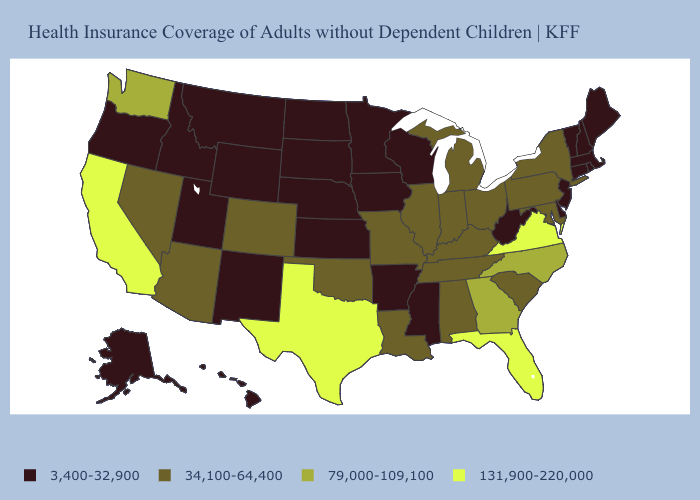Name the states that have a value in the range 79,000-109,100?
Be succinct. Georgia, North Carolina, Washington. Among the states that border Florida , which have the highest value?
Write a very short answer. Georgia. Does the map have missing data?
Keep it brief. No. Among the states that border Rhode Island , which have the lowest value?
Concise answer only. Connecticut, Massachusetts. What is the lowest value in the USA?
Keep it brief. 3,400-32,900. Among the states that border California , which have the lowest value?
Quick response, please. Oregon. What is the value of Nevada?
Concise answer only. 34,100-64,400. What is the value of Vermont?
Short answer required. 3,400-32,900. Name the states that have a value in the range 79,000-109,100?
Give a very brief answer. Georgia, North Carolina, Washington. What is the lowest value in the USA?
Short answer required. 3,400-32,900. Name the states that have a value in the range 3,400-32,900?
Quick response, please. Alaska, Arkansas, Connecticut, Delaware, Hawaii, Idaho, Iowa, Kansas, Maine, Massachusetts, Minnesota, Mississippi, Montana, Nebraska, New Hampshire, New Jersey, New Mexico, North Dakota, Oregon, Rhode Island, South Dakota, Utah, Vermont, West Virginia, Wisconsin, Wyoming. What is the value of Nevada?
Keep it brief. 34,100-64,400. Which states hav the highest value in the Northeast?
Quick response, please. New York, Pennsylvania. What is the value of Hawaii?
Write a very short answer. 3,400-32,900. Which states have the lowest value in the USA?
Concise answer only. Alaska, Arkansas, Connecticut, Delaware, Hawaii, Idaho, Iowa, Kansas, Maine, Massachusetts, Minnesota, Mississippi, Montana, Nebraska, New Hampshire, New Jersey, New Mexico, North Dakota, Oregon, Rhode Island, South Dakota, Utah, Vermont, West Virginia, Wisconsin, Wyoming. 